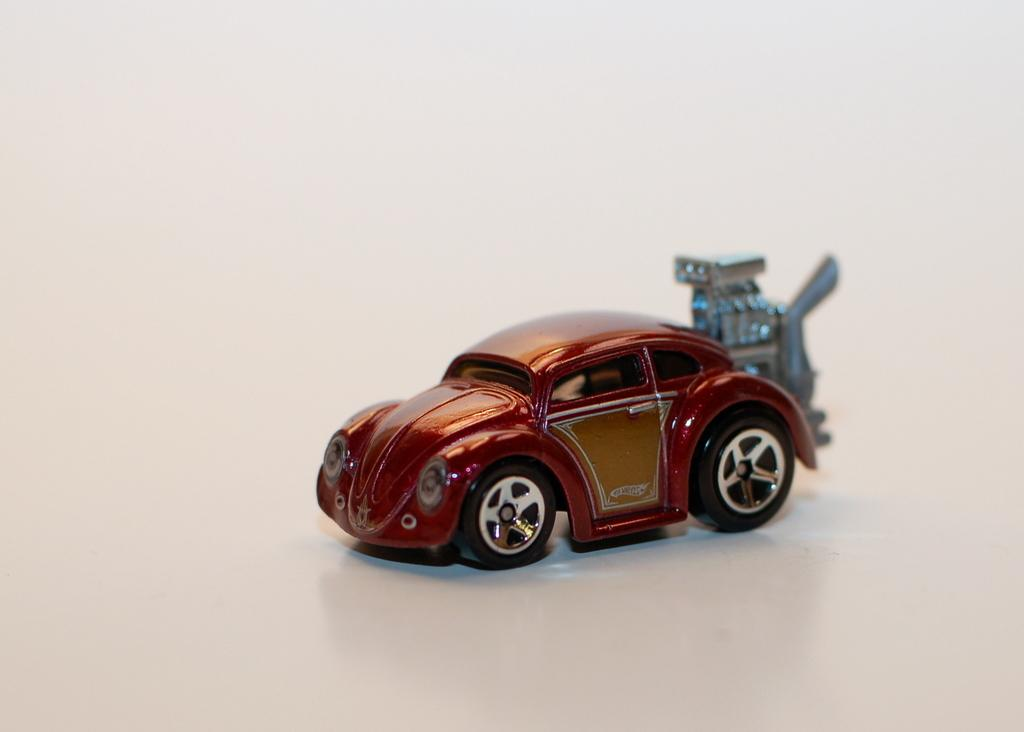What is the main subject of the image? The main subject of the image is a toy car. What color is the toy car? The toy car is red. What color is the background of the image? The background of the image is white. Can you see the curtain in the image? There is no curtain present in the image. Is the toy car walking in the image? Toys, including toy cars, do not walk; they are inanimate objects. 